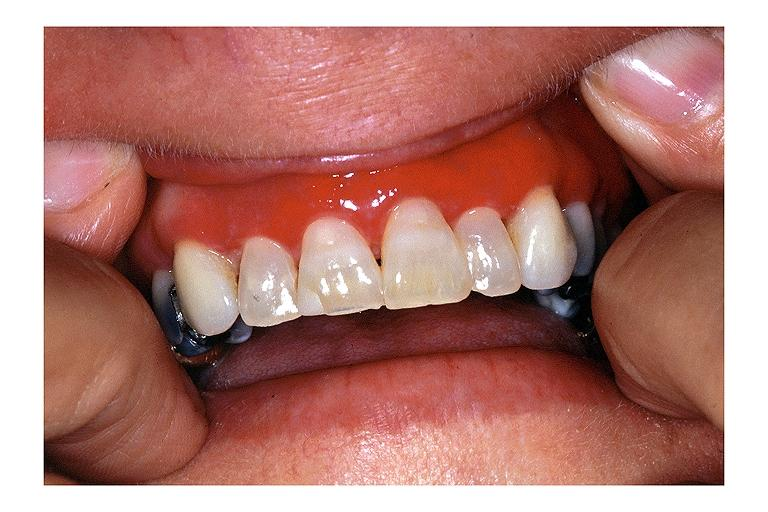does quite good liver show desquamative gingivits?
Answer the question using a single word or phrase. No 